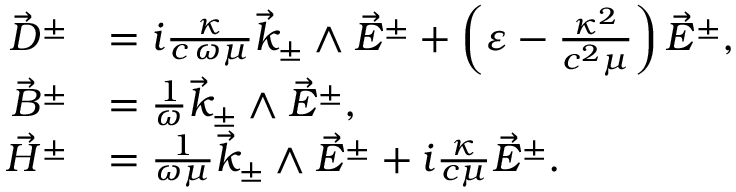Convert formula to latex. <formula><loc_0><loc_0><loc_500><loc_500>\begin{array} { r l } { \vec { D } ^ { \pm } } & { = i \frac { \kappa } { c \, \omega \mu } \vec { k } _ { \pm } \wedge \vec { E } ^ { \pm } + \left ( \varepsilon - \frac { \kappa ^ { 2 } } { c ^ { 2 } \mu } \right ) \vec { E } ^ { \pm } , } \\ { \vec { B } ^ { \pm } } & { = \frac { 1 } { \omega } \vec { k } _ { \pm } \wedge \vec { E } ^ { \pm } , } \\ { \vec { H } ^ { \pm } } & { = \frac { 1 } { \omega \mu } \vec { k } _ { \pm } \wedge \vec { E } ^ { \pm } + i \frac { \kappa } { c \mu } \vec { E } ^ { \pm } . } \end{array}</formula> 